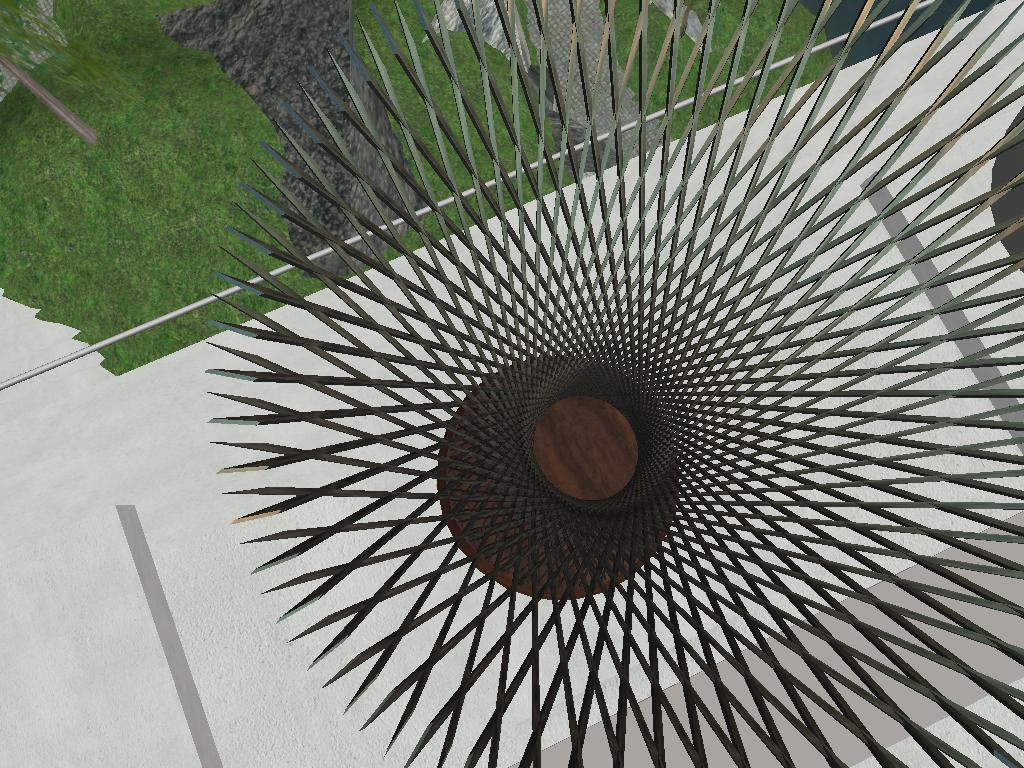What type of design is featured in the picture? There is an architectural design in the picture. What is the surface beneath the design? There is a ground in the picture. What type of vegetation is present on the ground? There is grass on the ground. Can you see any yaks grazing in the grass in the image? There are no yaks present in the image; it features an architectural design and grass on the ground. 